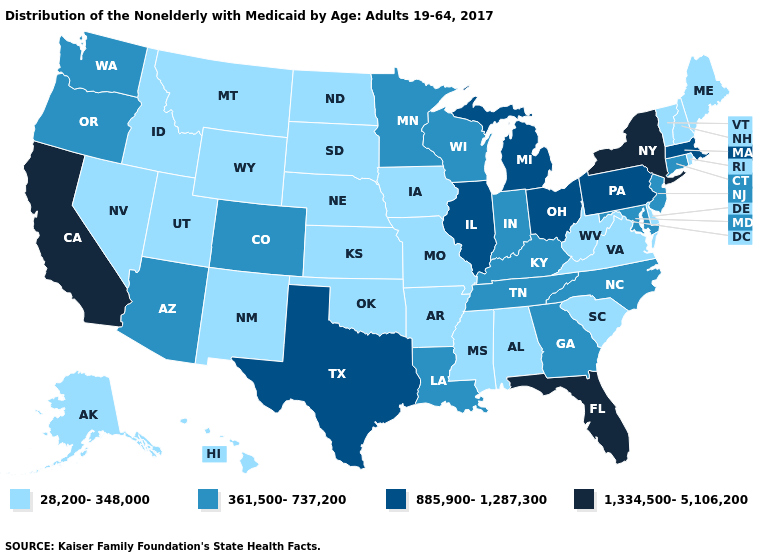Does Minnesota have the lowest value in the USA?
Keep it brief. No. What is the value of Wisconsin?
Quick response, please. 361,500-737,200. Does South Carolina have the lowest value in the South?
Give a very brief answer. Yes. Which states have the lowest value in the USA?
Be succinct. Alabama, Alaska, Arkansas, Delaware, Hawaii, Idaho, Iowa, Kansas, Maine, Mississippi, Missouri, Montana, Nebraska, Nevada, New Hampshire, New Mexico, North Dakota, Oklahoma, Rhode Island, South Carolina, South Dakota, Utah, Vermont, Virginia, West Virginia, Wyoming. What is the value of Washington?
Write a very short answer. 361,500-737,200. Among the states that border Minnesota , does Wisconsin have the highest value?
Short answer required. Yes. Name the states that have a value in the range 28,200-348,000?
Quick response, please. Alabama, Alaska, Arkansas, Delaware, Hawaii, Idaho, Iowa, Kansas, Maine, Mississippi, Missouri, Montana, Nebraska, Nevada, New Hampshire, New Mexico, North Dakota, Oklahoma, Rhode Island, South Carolina, South Dakota, Utah, Vermont, Virginia, West Virginia, Wyoming. Among the states that border North Dakota , which have the lowest value?
Quick response, please. Montana, South Dakota. Which states have the lowest value in the Northeast?
Concise answer only. Maine, New Hampshire, Rhode Island, Vermont. Name the states that have a value in the range 28,200-348,000?
Write a very short answer. Alabama, Alaska, Arkansas, Delaware, Hawaii, Idaho, Iowa, Kansas, Maine, Mississippi, Missouri, Montana, Nebraska, Nevada, New Hampshire, New Mexico, North Dakota, Oklahoma, Rhode Island, South Carolina, South Dakota, Utah, Vermont, Virginia, West Virginia, Wyoming. Name the states that have a value in the range 361,500-737,200?
Give a very brief answer. Arizona, Colorado, Connecticut, Georgia, Indiana, Kentucky, Louisiana, Maryland, Minnesota, New Jersey, North Carolina, Oregon, Tennessee, Washington, Wisconsin. Name the states that have a value in the range 28,200-348,000?
Short answer required. Alabama, Alaska, Arkansas, Delaware, Hawaii, Idaho, Iowa, Kansas, Maine, Mississippi, Missouri, Montana, Nebraska, Nevada, New Hampshire, New Mexico, North Dakota, Oklahoma, Rhode Island, South Carolina, South Dakota, Utah, Vermont, Virginia, West Virginia, Wyoming. What is the value of Oregon?
Concise answer only. 361,500-737,200. Name the states that have a value in the range 361,500-737,200?
Quick response, please. Arizona, Colorado, Connecticut, Georgia, Indiana, Kentucky, Louisiana, Maryland, Minnesota, New Jersey, North Carolina, Oregon, Tennessee, Washington, Wisconsin. What is the value of North Dakota?
Write a very short answer. 28,200-348,000. 